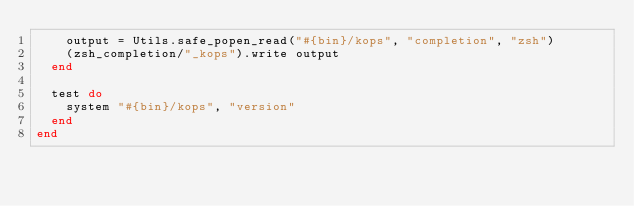Convert code to text. <code><loc_0><loc_0><loc_500><loc_500><_Ruby_>    output = Utils.safe_popen_read("#{bin}/kops", "completion", "zsh")
    (zsh_completion/"_kops").write output
  end

  test do
    system "#{bin}/kops", "version"
  end
end
</code> 